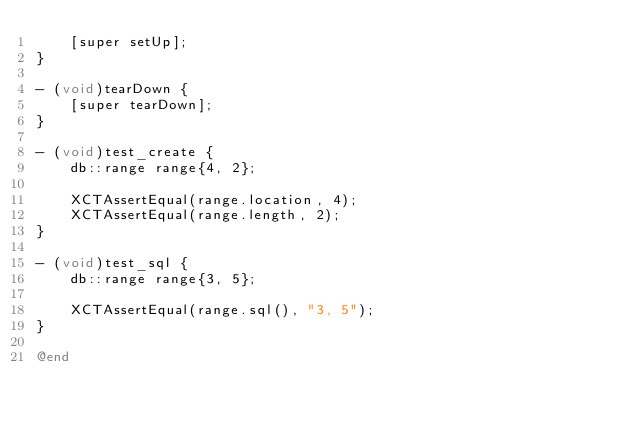Convert code to text. <code><loc_0><loc_0><loc_500><loc_500><_ObjectiveC_>    [super setUp];
}

- (void)tearDown {
    [super tearDown];
}

- (void)test_create {
    db::range range{4, 2};

    XCTAssertEqual(range.location, 4);
    XCTAssertEqual(range.length, 2);
}

- (void)test_sql {
    db::range range{3, 5};

    XCTAssertEqual(range.sql(), "3, 5");
}

@end
</code> 